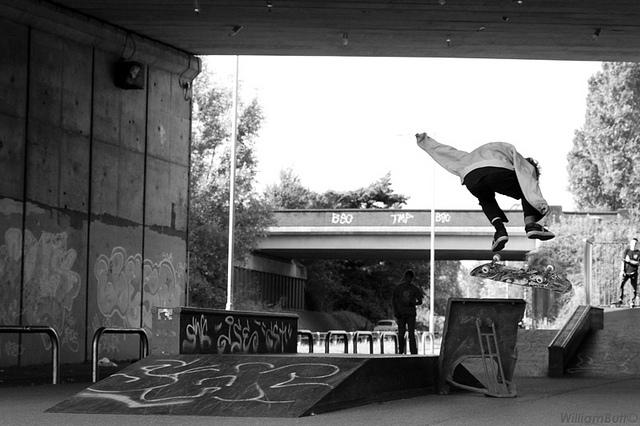How many graffiti pictures are on the overpass wall? Please explain your reasoning. three. There are 3 pictures. 